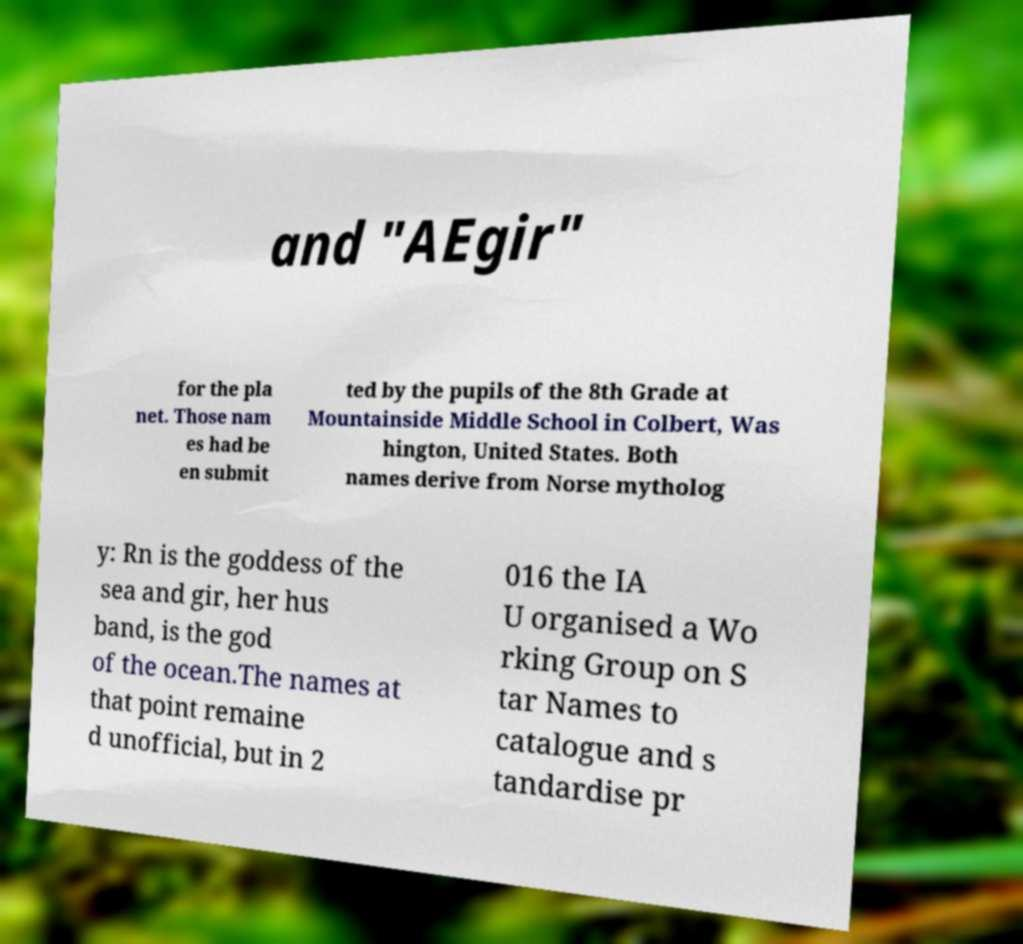Please identify and transcribe the text found in this image. and "AEgir" for the pla net. Those nam es had be en submit ted by the pupils of the 8th Grade at Mountainside Middle School in Colbert, Was hington, United States. Both names derive from Norse mytholog y: Rn is the goddess of the sea and gir, her hus band, is the god of the ocean.The names at that point remaine d unofficial, but in 2 016 the IA U organised a Wo rking Group on S tar Names to catalogue and s tandardise pr 